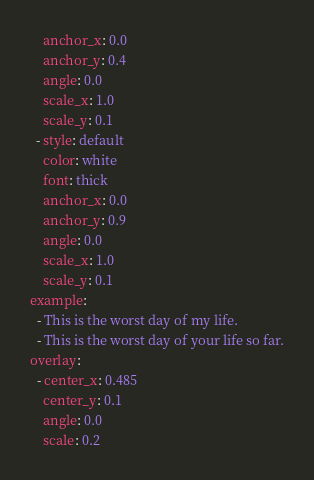Convert code to text. <code><loc_0><loc_0><loc_500><loc_500><_YAML_>    anchor_x: 0.0
    anchor_y: 0.4
    angle: 0.0
    scale_x: 1.0
    scale_y: 0.1
  - style: default
    color: white
    font: thick
    anchor_x: 0.0
    anchor_y: 0.9
    angle: 0.0
    scale_x: 1.0
    scale_y: 0.1
example:
  - This is the worst day of my life.
  - This is the worst day of your life so far.
overlay:
  - center_x: 0.485
    center_y: 0.1
    angle: 0.0
    scale: 0.2
</code> 